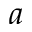Convert formula to latex. <formula><loc_0><loc_0><loc_500><loc_500>a</formula> 